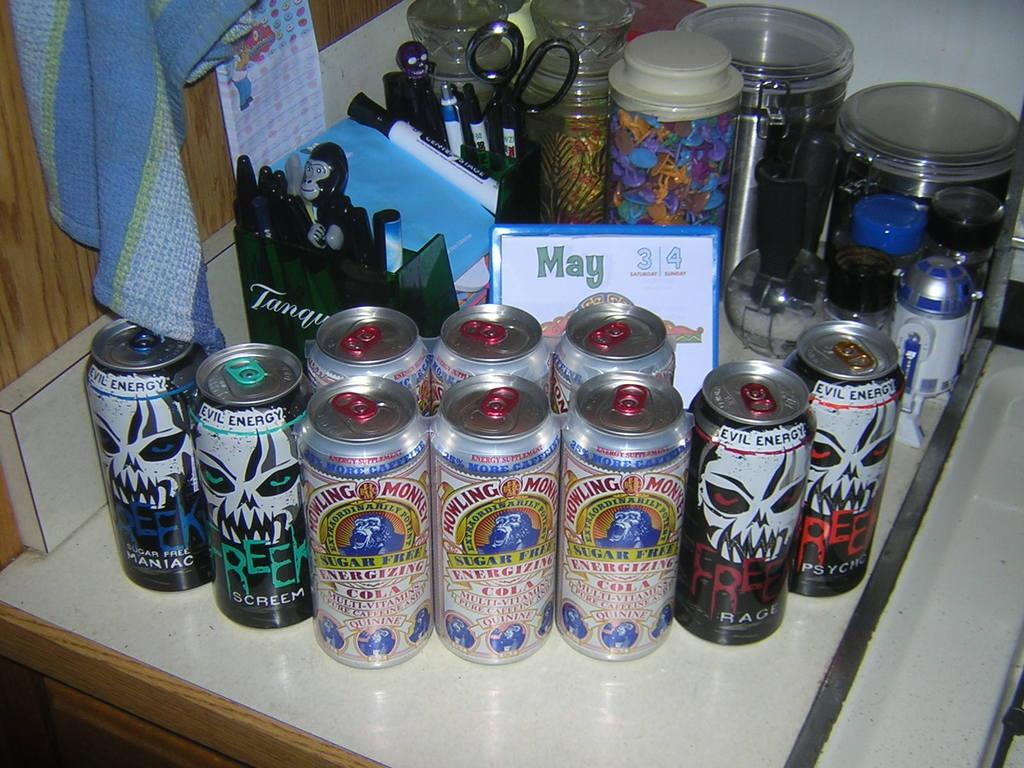<image>
Write a terse but informative summary of the picture. A can of Howling Monkey next to cans of Freek. 